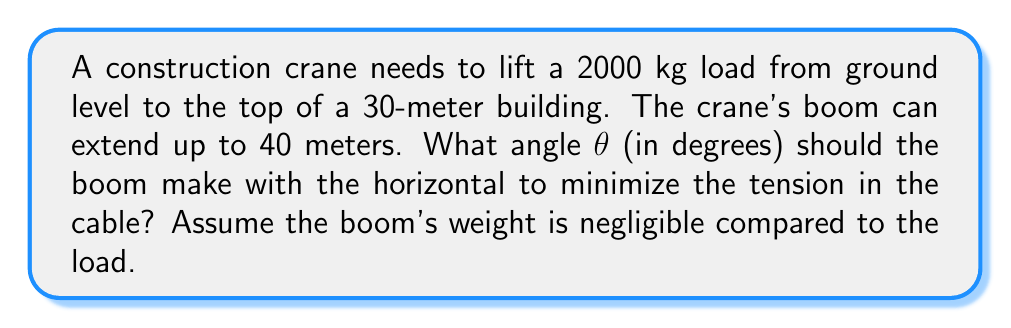Give your solution to this math problem. Let's approach this step-by-step:

1) First, we need to set up our problem. We have a right triangle where:
   - The adjacent side (horizontal distance) is x
   - The opposite side (height of building) is 30 meters
   - The hypotenuse (length of boom) is 40 meters

2) We can express the tension T in the cable as a function of θ:

   $$T = \frac{mg}{\sin θ}$$

   where m is the mass (2000 kg) and g is the acceleration due to gravity (9.8 m/s²).

3) To minimize T, we need to maximize sin θ.

4) From the right triangle, we know:

   $$\sin θ = \frac{30}{40} = 0.75$$

5) Therefore, the optimal angle is:

   $$θ = \arcsin(0.75)$$

6) Converting to degrees:

   $$θ = \arcsin(0.75) \cdot \frac{180°}{\pi} ≈ 48.59°$$

[asy]
import geometry;

size(200);
pair A=(0,0), B=(80,0), C=(0,60);
draw(A--B--C--A);
draw(A--C,dashed);
label("30m",A--C,W);
label("40m",B--C,NE);
label("θ",A,NE);
label("x",A--B,S);
[/asy]

This angle ensures that the tension in the cable is minimized, thus maximizing the crane's efficiency.
Answer: 48.59° 